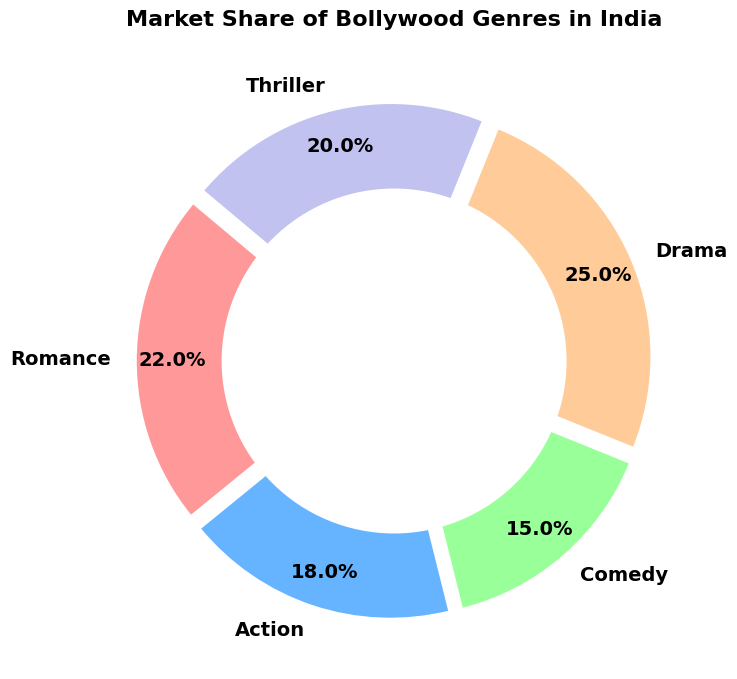Which genre has the highest market share? The Drama genre has the largest slice in the ring chart, which indicates the highest market share.
Answer: Drama Which genre has the lowest market share? The Comedy genre has the smallest slice in the ring chart, indicating the lowest market share.
Answer: Comedy What’s the combined market share of Action and Thriller genres? Add the market shares of Action (18%) and Thriller (20%) genres. 18% + 20% = 38%.
Answer: 38% How much larger is the market share of Romance compared to Comedy? Subtract the market share of Comedy (15%) from the market share of Romance (22%). 22% - 15% = 7%.
Answer: 7% What is the difference in market share between Drama and Action genres? Subtract the market share of Action (18%) from the market share of Drama (25%). 25% - 18% = 7%.
Answer: 7% Which genres have a market share greater than 20%? Identify the genres with market share values greater than 20%. Both Drama (25%) and Romance (22%) have market shares greater than 20%.
Answer: Drama, Romance By how much does the market share of Thriller exceed that of Comedy? Subtract the market share of Comedy (15%) from the market share of Thriller (20%). 20% - 15% = 5%.
Answer: 5% If the market share of each genre was equally shared, what would be the market share percentage for each genre? There are 5 genres, so the total market share (100%) divided by 5 would be equally shared. 100% / 5 = 20%.
Answer: 20% Which genre is represented by the green slice in the ring chart? Observe that the green slice corresponds to the Thriller genre.
Answer: Thriller Are there any genres with equal market share? Review the market share values of each genre. No two genres have the same market share in this chart.
Answer: No 